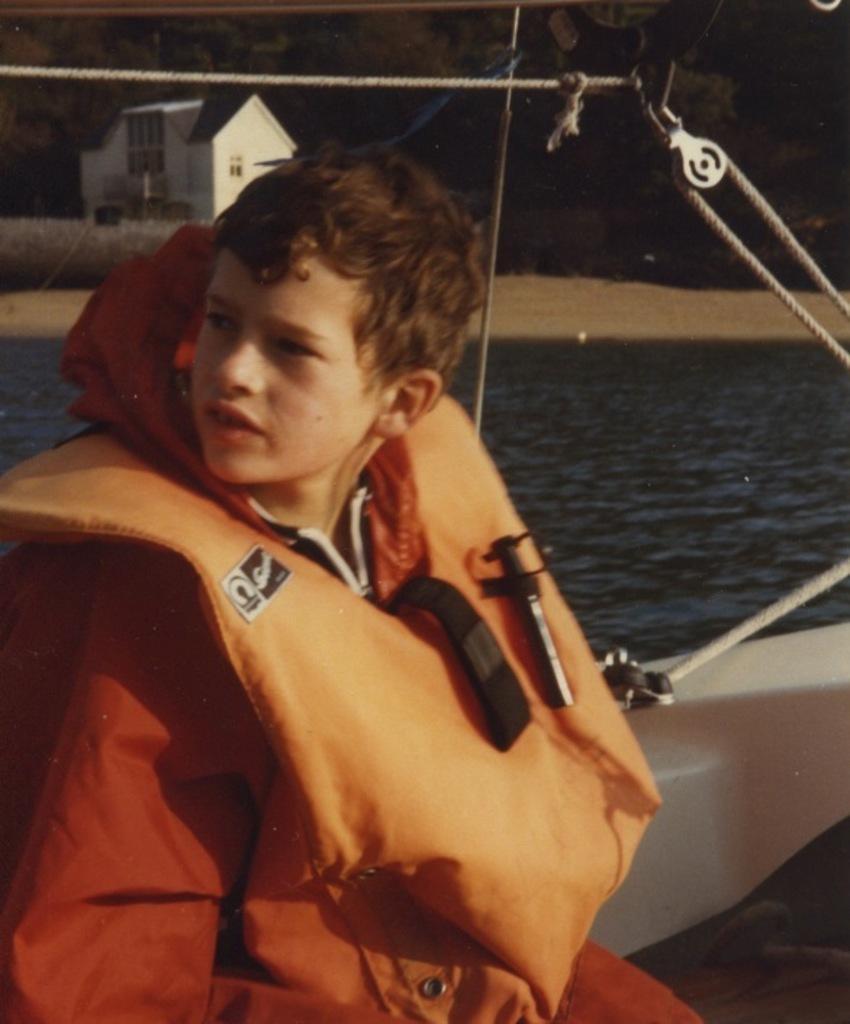Can you describe this image briefly? In this image I can see a boy in the front and I can see he is wearing an orange colour life jacket. I can also see few ropes in the front and in the background I can see water, number of trees and a white colour building. 